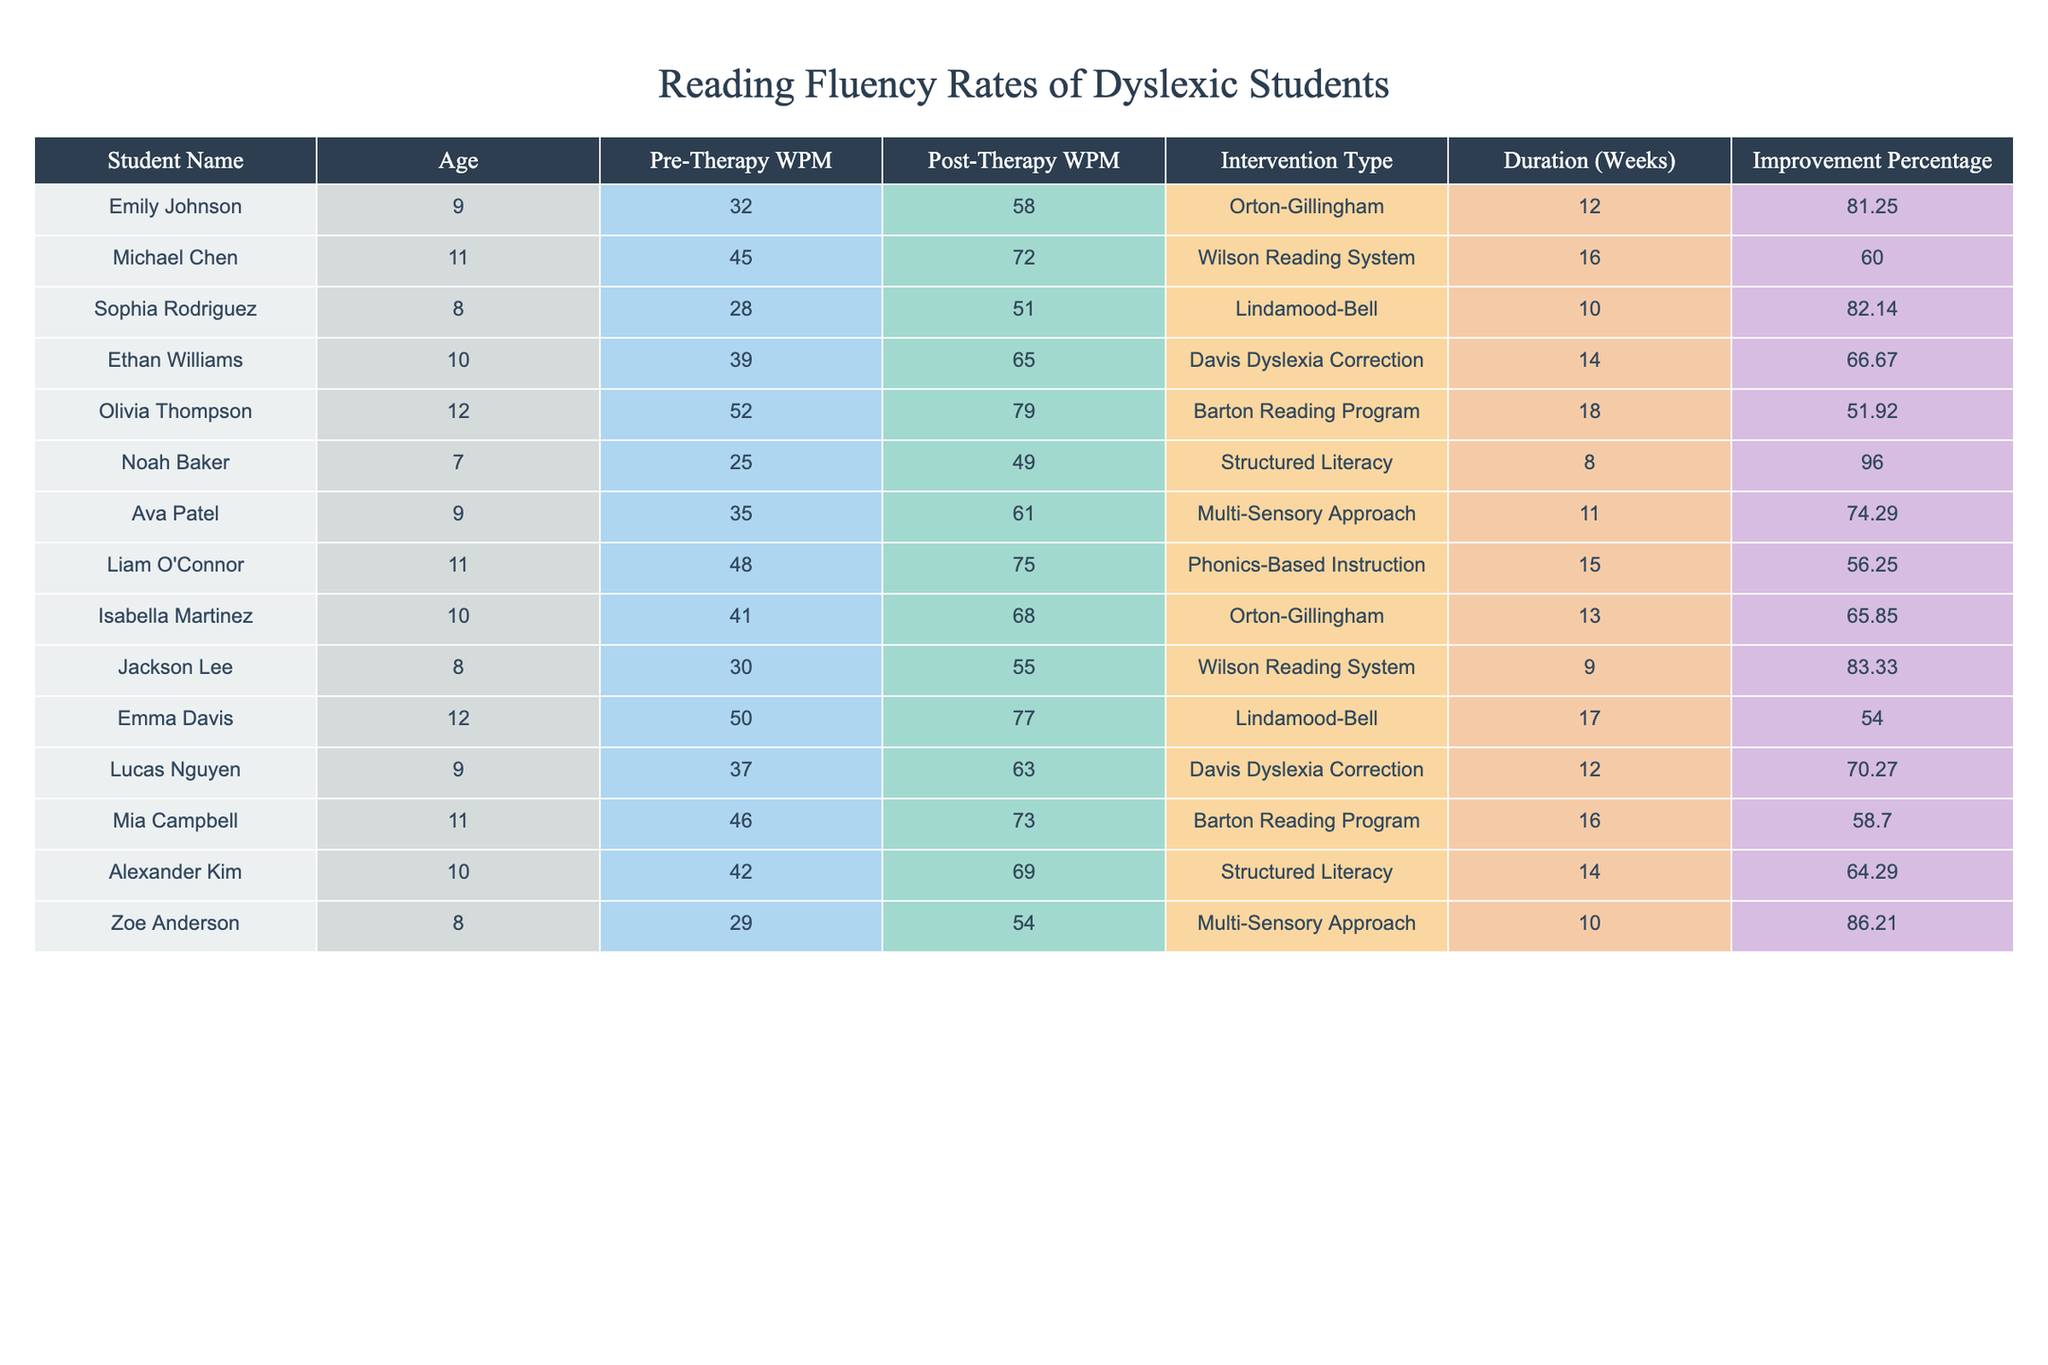What is the highest improvement percentage recorded in this table? By examining the "Improvement Percentage" column, the highest value is 96.00% as seen with Noah Baker.
Answer: 96.00% What was Emily Johnson's pre-therapy WPM? The "Pre-Therapy WPM" for Emily Johnson is listed as 32 in the table.
Answer: 32 How many students improved their reading speed by more than 80%? To find this, we look through the "Improvement Percentage" column and see that both Noah Baker (96.00%) and Sophia Rodriguez (82.14%) improved by more than 80%, resulting in a total of 2 students.
Answer: 2 What is the average post-therapy WPM of all students in the table? The post-therapy WPM values are summed: (58 + 72 + 51 + 65 + 79 + 49 + 61 + 75 + 68 + 55 + 77 + 63 + 73 + 69 + 54) = 1031. Since there are 15 students, the average is 1031/15 = 68.73.
Answer: 68.73 Did any student have a higher pre-therapy WPM than 50? Checking the "Pre-Therapy WPM" column, we see that Olivia Thompson, Mia Campbell, and Michael Chen all have pre-therapy WPM values greater than 50, confirming that yes, there are students above this threshold.
Answer: Yes Which intervention type had the lowest improvement? By reviewing the "Improvement Percentage" column, the lowest recorded improvement is 51.92% with Olivia Thompson who used the Barton Reading Program.
Answer: Barton Reading Program What is the difference between the highest and lowest pre-therapy WPM in the table? The highest pre-therapy WPM is 52 (Olivia Thompson), while the lowest is 25 (Noah Baker). Thus, the difference is 52 - 25 = 27.
Answer: 27 Which age group had the most students listed in the table? Counting the number of students per age, we find that 11-year-olds (Michael Chen, Liam O'Connor, and Mia Campbell) have the most with 3 students.
Answer: 11 What percentage of students improved their reading speed by 60% or more? There are 7 students with an improvement percentage 60% or higher: Emily Johnson, Michael Chen, Sophia Rodriguez, Ethan Williams, Lucas Nguyen, and Zoe Anderson out of 15 total students; thus, (7/15) * 100 = 46.67%.
Answer: 46.67% Is there a relationship between age and improvement percentage based on this table? While the data does not explicitly show a clear correlation, both younger students (like Noah Baker and Zoe Anderson) achieved higher improvement percentages. However, a definitive statistical analysis would require additional calculations. Thus, we cannot conclude definitively from the table alone.
Answer: No definitive conclusion 